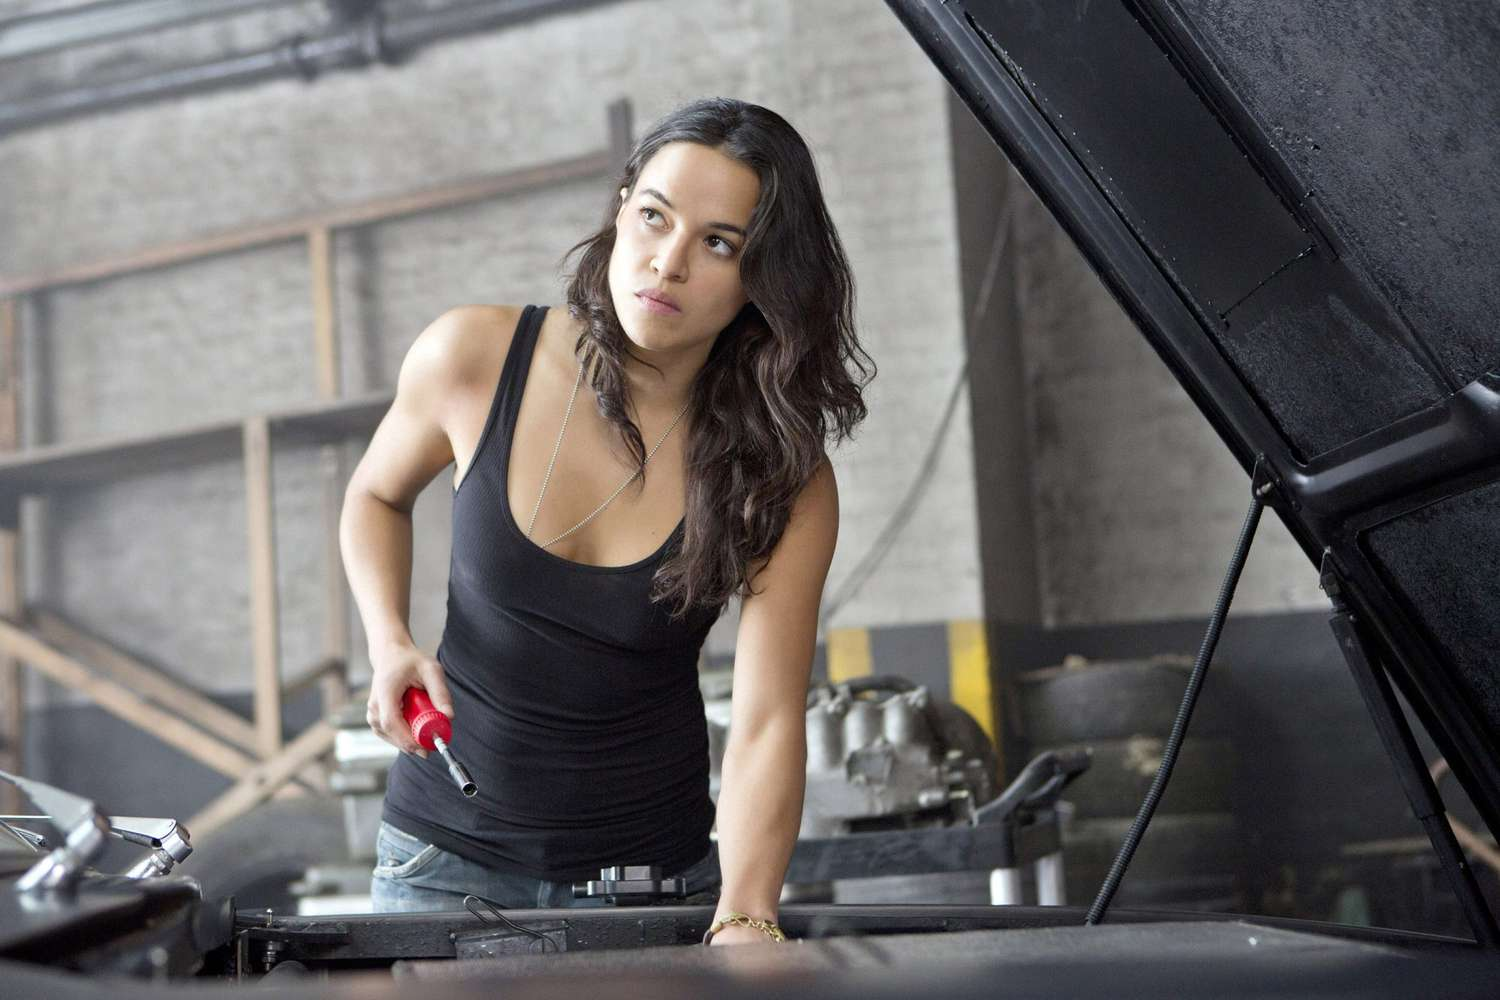What kind of emotions do you think she is experiencing? The woman in the image seems to be experiencing a mix of intense concentration and determination. Her serious expression indicates that she is deeply focused on the task at hand, possibly feeling a sense of responsibility and urgency. There might also be an undercurrent of pride in her capabilities, as she appears confident in handling the mechanical work. This combination of emotions highlights her commitment and the importance she places on getting the job done right. 